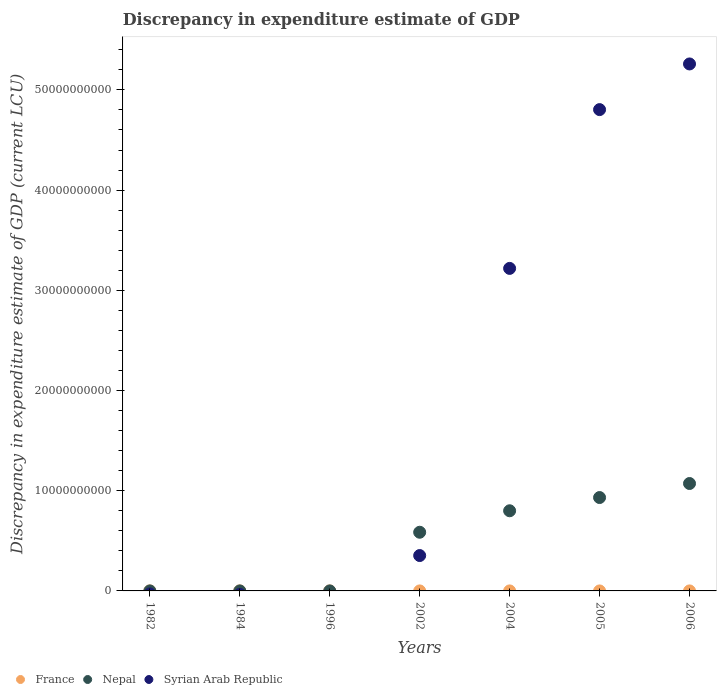What is the discrepancy in expenditure estimate of GDP in Nepal in 1984?
Your response must be concise. 9.9e-5. Across all years, what is the maximum discrepancy in expenditure estimate of GDP in Syrian Arab Republic?
Keep it short and to the point. 5.26e+1. What is the total discrepancy in expenditure estimate of GDP in Nepal in the graph?
Provide a succinct answer. 3.39e+1. What is the difference between the discrepancy in expenditure estimate of GDP in Syrian Arab Republic in 2004 and that in 2005?
Give a very brief answer. -1.58e+1. What is the average discrepancy in expenditure estimate of GDP in Nepal per year?
Provide a succinct answer. 4.84e+09. In the year 2002, what is the difference between the discrepancy in expenditure estimate of GDP in Nepal and discrepancy in expenditure estimate of GDP in Syrian Arab Republic?
Provide a short and direct response. 2.33e+09. Is the difference between the discrepancy in expenditure estimate of GDP in Nepal in 2004 and 2005 greater than the difference between the discrepancy in expenditure estimate of GDP in Syrian Arab Republic in 2004 and 2005?
Keep it short and to the point. Yes. What is the difference between the highest and the second highest discrepancy in expenditure estimate of GDP in France?
Your answer should be compact. 0. What is the difference between the highest and the lowest discrepancy in expenditure estimate of GDP in Nepal?
Ensure brevity in your answer.  1.07e+1. In how many years, is the discrepancy in expenditure estimate of GDP in Syrian Arab Republic greater than the average discrepancy in expenditure estimate of GDP in Syrian Arab Republic taken over all years?
Give a very brief answer. 3. Is the sum of the discrepancy in expenditure estimate of GDP in Syrian Arab Republic in 2002 and 2004 greater than the maximum discrepancy in expenditure estimate of GDP in Nepal across all years?
Make the answer very short. Yes. Is it the case that in every year, the sum of the discrepancy in expenditure estimate of GDP in Syrian Arab Republic and discrepancy in expenditure estimate of GDP in France  is greater than the discrepancy in expenditure estimate of GDP in Nepal?
Provide a succinct answer. No. Is the discrepancy in expenditure estimate of GDP in Syrian Arab Republic strictly greater than the discrepancy in expenditure estimate of GDP in France over the years?
Give a very brief answer. No. Is the discrepancy in expenditure estimate of GDP in Nepal strictly less than the discrepancy in expenditure estimate of GDP in France over the years?
Offer a terse response. No. How many dotlines are there?
Provide a short and direct response. 3. How many years are there in the graph?
Your response must be concise. 7. Are the values on the major ticks of Y-axis written in scientific E-notation?
Make the answer very short. No. Does the graph contain grids?
Your answer should be compact. No. How are the legend labels stacked?
Your response must be concise. Horizontal. What is the title of the graph?
Offer a very short reply. Discrepancy in expenditure estimate of GDP. Does "Azerbaijan" appear as one of the legend labels in the graph?
Keep it short and to the point. No. What is the label or title of the Y-axis?
Provide a short and direct response. Discrepancy in expenditure estimate of GDP (current LCU). What is the Discrepancy in expenditure estimate of GDP (current LCU) of France in 1982?
Give a very brief answer. 1.00e+06. What is the Discrepancy in expenditure estimate of GDP (current LCU) of Syrian Arab Republic in 1982?
Provide a succinct answer. 0. What is the Discrepancy in expenditure estimate of GDP (current LCU) of Nepal in 1984?
Keep it short and to the point. 9.9e-5. What is the Discrepancy in expenditure estimate of GDP (current LCU) in Syrian Arab Republic in 1984?
Provide a succinct answer. 0. What is the Discrepancy in expenditure estimate of GDP (current LCU) in France in 1996?
Make the answer very short. 0. What is the Discrepancy in expenditure estimate of GDP (current LCU) in France in 2002?
Your answer should be very brief. 1.00e+06. What is the Discrepancy in expenditure estimate of GDP (current LCU) of Nepal in 2002?
Give a very brief answer. 5.86e+09. What is the Discrepancy in expenditure estimate of GDP (current LCU) of Syrian Arab Republic in 2002?
Keep it short and to the point. 3.53e+09. What is the Discrepancy in expenditure estimate of GDP (current LCU) in France in 2004?
Provide a short and direct response. 1.00e+06. What is the Discrepancy in expenditure estimate of GDP (current LCU) of Nepal in 2004?
Your response must be concise. 8.00e+09. What is the Discrepancy in expenditure estimate of GDP (current LCU) of Syrian Arab Republic in 2004?
Your response must be concise. 3.22e+1. What is the Discrepancy in expenditure estimate of GDP (current LCU) of Nepal in 2005?
Your response must be concise. 9.32e+09. What is the Discrepancy in expenditure estimate of GDP (current LCU) of Syrian Arab Republic in 2005?
Offer a very short reply. 4.80e+1. What is the Discrepancy in expenditure estimate of GDP (current LCU) in Nepal in 2006?
Provide a short and direct response. 1.07e+1. What is the Discrepancy in expenditure estimate of GDP (current LCU) of Syrian Arab Republic in 2006?
Your response must be concise. 5.26e+1. Across all years, what is the maximum Discrepancy in expenditure estimate of GDP (current LCU) in France?
Your response must be concise. 1.00e+06. Across all years, what is the maximum Discrepancy in expenditure estimate of GDP (current LCU) in Nepal?
Your response must be concise. 1.07e+1. Across all years, what is the maximum Discrepancy in expenditure estimate of GDP (current LCU) in Syrian Arab Republic?
Give a very brief answer. 5.26e+1. Across all years, what is the minimum Discrepancy in expenditure estimate of GDP (current LCU) of France?
Offer a terse response. 0. What is the total Discrepancy in expenditure estimate of GDP (current LCU) of France in the graph?
Your answer should be compact. 5.00e+06. What is the total Discrepancy in expenditure estimate of GDP (current LCU) of Nepal in the graph?
Provide a short and direct response. 3.39e+1. What is the total Discrepancy in expenditure estimate of GDP (current LCU) in Syrian Arab Republic in the graph?
Your answer should be compact. 1.36e+11. What is the difference between the Discrepancy in expenditure estimate of GDP (current LCU) in France in 1982 and that in 1984?
Your answer should be compact. 0. What is the difference between the Discrepancy in expenditure estimate of GDP (current LCU) in France in 1982 and that in 2006?
Ensure brevity in your answer.  0. What is the difference between the Discrepancy in expenditure estimate of GDP (current LCU) of Nepal in 1984 and that in 2002?
Keep it short and to the point. -5.85e+09. What is the difference between the Discrepancy in expenditure estimate of GDP (current LCU) of France in 1984 and that in 2004?
Keep it short and to the point. 0. What is the difference between the Discrepancy in expenditure estimate of GDP (current LCU) of Nepal in 1984 and that in 2004?
Give a very brief answer. -8.00e+09. What is the difference between the Discrepancy in expenditure estimate of GDP (current LCU) in Nepal in 1984 and that in 2005?
Your answer should be very brief. -9.32e+09. What is the difference between the Discrepancy in expenditure estimate of GDP (current LCU) in Nepal in 1984 and that in 2006?
Your response must be concise. -1.07e+1. What is the difference between the Discrepancy in expenditure estimate of GDP (current LCU) of France in 2002 and that in 2004?
Your answer should be compact. 0. What is the difference between the Discrepancy in expenditure estimate of GDP (current LCU) in Nepal in 2002 and that in 2004?
Give a very brief answer. -2.14e+09. What is the difference between the Discrepancy in expenditure estimate of GDP (current LCU) in Syrian Arab Republic in 2002 and that in 2004?
Provide a succinct answer. -2.87e+1. What is the difference between the Discrepancy in expenditure estimate of GDP (current LCU) of Nepal in 2002 and that in 2005?
Your answer should be very brief. -3.46e+09. What is the difference between the Discrepancy in expenditure estimate of GDP (current LCU) of Syrian Arab Republic in 2002 and that in 2005?
Offer a terse response. -4.45e+1. What is the difference between the Discrepancy in expenditure estimate of GDP (current LCU) in Nepal in 2002 and that in 2006?
Your answer should be compact. -4.86e+09. What is the difference between the Discrepancy in expenditure estimate of GDP (current LCU) of Syrian Arab Republic in 2002 and that in 2006?
Keep it short and to the point. -4.91e+1. What is the difference between the Discrepancy in expenditure estimate of GDP (current LCU) of Nepal in 2004 and that in 2005?
Give a very brief answer. -1.32e+09. What is the difference between the Discrepancy in expenditure estimate of GDP (current LCU) in Syrian Arab Republic in 2004 and that in 2005?
Your answer should be compact. -1.58e+1. What is the difference between the Discrepancy in expenditure estimate of GDP (current LCU) of France in 2004 and that in 2006?
Offer a very short reply. 0. What is the difference between the Discrepancy in expenditure estimate of GDP (current LCU) of Nepal in 2004 and that in 2006?
Make the answer very short. -2.72e+09. What is the difference between the Discrepancy in expenditure estimate of GDP (current LCU) in Syrian Arab Republic in 2004 and that in 2006?
Give a very brief answer. -2.04e+1. What is the difference between the Discrepancy in expenditure estimate of GDP (current LCU) of Nepal in 2005 and that in 2006?
Give a very brief answer. -1.40e+09. What is the difference between the Discrepancy in expenditure estimate of GDP (current LCU) of Syrian Arab Republic in 2005 and that in 2006?
Your response must be concise. -4.56e+09. What is the difference between the Discrepancy in expenditure estimate of GDP (current LCU) of France in 1982 and the Discrepancy in expenditure estimate of GDP (current LCU) of Nepal in 1984?
Ensure brevity in your answer.  1.00e+06. What is the difference between the Discrepancy in expenditure estimate of GDP (current LCU) of France in 1982 and the Discrepancy in expenditure estimate of GDP (current LCU) of Nepal in 2002?
Your answer should be compact. -5.85e+09. What is the difference between the Discrepancy in expenditure estimate of GDP (current LCU) of France in 1982 and the Discrepancy in expenditure estimate of GDP (current LCU) of Syrian Arab Republic in 2002?
Keep it short and to the point. -3.53e+09. What is the difference between the Discrepancy in expenditure estimate of GDP (current LCU) of France in 1982 and the Discrepancy in expenditure estimate of GDP (current LCU) of Nepal in 2004?
Offer a very short reply. -8.00e+09. What is the difference between the Discrepancy in expenditure estimate of GDP (current LCU) in France in 1982 and the Discrepancy in expenditure estimate of GDP (current LCU) in Syrian Arab Republic in 2004?
Your answer should be compact. -3.22e+1. What is the difference between the Discrepancy in expenditure estimate of GDP (current LCU) in France in 1982 and the Discrepancy in expenditure estimate of GDP (current LCU) in Nepal in 2005?
Offer a terse response. -9.32e+09. What is the difference between the Discrepancy in expenditure estimate of GDP (current LCU) in France in 1982 and the Discrepancy in expenditure estimate of GDP (current LCU) in Syrian Arab Republic in 2005?
Your response must be concise. -4.80e+1. What is the difference between the Discrepancy in expenditure estimate of GDP (current LCU) of France in 1982 and the Discrepancy in expenditure estimate of GDP (current LCU) of Nepal in 2006?
Your answer should be compact. -1.07e+1. What is the difference between the Discrepancy in expenditure estimate of GDP (current LCU) in France in 1982 and the Discrepancy in expenditure estimate of GDP (current LCU) in Syrian Arab Republic in 2006?
Your answer should be compact. -5.26e+1. What is the difference between the Discrepancy in expenditure estimate of GDP (current LCU) of France in 1984 and the Discrepancy in expenditure estimate of GDP (current LCU) of Nepal in 2002?
Your answer should be very brief. -5.85e+09. What is the difference between the Discrepancy in expenditure estimate of GDP (current LCU) of France in 1984 and the Discrepancy in expenditure estimate of GDP (current LCU) of Syrian Arab Republic in 2002?
Keep it short and to the point. -3.53e+09. What is the difference between the Discrepancy in expenditure estimate of GDP (current LCU) of Nepal in 1984 and the Discrepancy in expenditure estimate of GDP (current LCU) of Syrian Arab Republic in 2002?
Offer a terse response. -3.53e+09. What is the difference between the Discrepancy in expenditure estimate of GDP (current LCU) in France in 1984 and the Discrepancy in expenditure estimate of GDP (current LCU) in Nepal in 2004?
Keep it short and to the point. -8.00e+09. What is the difference between the Discrepancy in expenditure estimate of GDP (current LCU) of France in 1984 and the Discrepancy in expenditure estimate of GDP (current LCU) of Syrian Arab Republic in 2004?
Provide a short and direct response. -3.22e+1. What is the difference between the Discrepancy in expenditure estimate of GDP (current LCU) in Nepal in 1984 and the Discrepancy in expenditure estimate of GDP (current LCU) in Syrian Arab Republic in 2004?
Give a very brief answer. -3.22e+1. What is the difference between the Discrepancy in expenditure estimate of GDP (current LCU) in France in 1984 and the Discrepancy in expenditure estimate of GDP (current LCU) in Nepal in 2005?
Make the answer very short. -9.32e+09. What is the difference between the Discrepancy in expenditure estimate of GDP (current LCU) of France in 1984 and the Discrepancy in expenditure estimate of GDP (current LCU) of Syrian Arab Republic in 2005?
Keep it short and to the point. -4.80e+1. What is the difference between the Discrepancy in expenditure estimate of GDP (current LCU) in Nepal in 1984 and the Discrepancy in expenditure estimate of GDP (current LCU) in Syrian Arab Republic in 2005?
Your response must be concise. -4.80e+1. What is the difference between the Discrepancy in expenditure estimate of GDP (current LCU) of France in 1984 and the Discrepancy in expenditure estimate of GDP (current LCU) of Nepal in 2006?
Your answer should be compact. -1.07e+1. What is the difference between the Discrepancy in expenditure estimate of GDP (current LCU) in France in 1984 and the Discrepancy in expenditure estimate of GDP (current LCU) in Syrian Arab Republic in 2006?
Keep it short and to the point. -5.26e+1. What is the difference between the Discrepancy in expenditure estimate of GDP (current LCU) of Nepal in 1984 and the Discrepancy in expenditure estimate of GDP (current LCU) of Syrian Arab Republic in 2006?
Make the answer very short. -5.26e+1. What is the difference between the Discrepancy in expenditure estimate of GDP (current LCU) in France in 2002 and the Discrepancy in expenditure estimate of GDP (current LCU) in Nepal in 2004?
Ensure brevity in your answer.  -8.00e+09. What is the difference between the Discrepancy in expenditure estimate of GDP (current LCU) of France in 2002 and the Discrepancy in expenditure estimate of GDP (current LCU) of Syrian Arab Republic in 2004?
Your answer should be compact. -3.22e+1. What is the difference between the Discrepancy in expenditure estimate of GDP (current LCU) in Nepal in 2002 and the Discrepancy in expenditure estimate of GDP (current LCU) in Syrian Arab Republic in 2004?
Give a very brief answer. -2.63e+1. What is the difference between the Discrepancy in expenditure estimate of GDP (current LCU) in France in 2002 and the Discrepancy in expenditure estimate of GDP (current LCU) in Nepal in 2005?
Give a very brief answer. -9.32e+09. What is the difference between the Discrepancy in expenditure estimate of GDP (current LCU) in France in 2002 and the Discrepancy in expenditure estimate of GDP (current LCU) in Syrian Arab Republic in 2005?
Give a very brief answer. -4.80e+1. What is the difference between the Discrepancy in expenditure estimate of GDP (current LCU) of Nepal in 2002 and the Discrepancy in expenditure estimate of GDP (current LCU) of Syrian Arab Republic in 2005?
Your response must be concise. -4.22e+1. What is the difference between the Discrepancy in expenditure estimate of GDP (current LCU) of France in 2002 and the Discrepancy in expenditure estimate of GDP (current LCU) of Nepal in 2006?
Your answer should be very brief. -1.07e+1. What is the difference between the Discrepancy in expenditure estimate of GDP (current LCU) in France in 2002 and the Discrepancy in expenditure estimate of GDP (current LCU) in Syrian Arab Republic in 2006?
Your response must be concise. -5.26e+1. What is the difference between the Discrepancy in expenditure estimate of GDP (current LCU) of Nepal in 2002 and the Discrepancy in expenditure estimate of GDP (current LCU) of Syrian Arab Republic in 2006?
Make the answer very short. -4.67e+1. What is the difference between the Discrepancy in expenditure estimate of GDP (current LCU) of France in 2004 and the Discrepancy in expenditure estimate of GDP (current LCU) of Nepal in 2005?
Offer a very short reply. -9.32e+09. What is the difference between the Discrepancy in expenditure estimate of GDP (current LCU) in France in 2004 and the Discrepancy in expenditure estimate of GDP (current LCU) in Syrian Arab Republic in 2005?
Make the answer very short. -4.80e+1. What is the difference between the Discrepancy in expenditure estimate of GDP (current LCU) of Nepal in 2004 and the Discrepancy in expenditure estimate of GDP (current LCU) of Syrian Arab Republic in 2005?
Your answer should be very brief. -4.00e+1. What is the difference between the Discrepancy in expenditure estimate of GDP (current LCU) in France in 2004 and the Discrepancy in expenditure estimate of GDP (current LCU) in Nepal in 2006?
Make the answer very short. -1.07e+1. What is the difference between the Discrepancy in expenditure estimate of GDP (current LCU) of France in 2004 and the Discrepancy in expenditure estimate of GDP (current LCU) of Syrian Arab Republic in 2006?
Make the answer very short. -5.26e+1. What is the difference between the Discrepancy in expenditure estimate of GDP (current LCU) in Nepal in 2004 and the Discrepancy in expenditure estimate of GDP (current LCU) in Syrian Arab Republic in 2006?
Make the answer very short. -4.46e+1. What is the difference between the Discrepancy in expenditure estimate of GDP (current LCU) in Nepal in 2005 and the Discrepancy in expenditure estimate of GDP (current LCU) in Syrian Arab Republic in 2006?
Your answer should be very brief. -4.33e+1. What is the average Discrepancy in expenditure estimate of GDP (current LCU) in France per year?
Make the answer very short. 7.14e+05. What is the average Discrepancy in expenditure estimate of GDP (current LCU) in Nepal per year?
Provide a succinct answer. 4.84e+09. What is the average Discrepancy in expenditure estimate of GDP (current LCU) of Syrian Arab Republic per year?
Offer a terse response. 1.95e+1. In the year 1984, what is the difference between the Discrepancy in expenditure estimate of GDP (current LCU) of France and Discrepancy in expenditure estimate of GDP (current LCU) of Nepal?
Your response must be concise. 1.00e+06. In the year 2002, what is the difference between the Discrepancy in expenditure estimate of GDP (current LCU) in France and Discrepancy in expenditure estimate of GDP (current LCU) in Nepal?
Provide a short and direct response. -5.85e+09. In the year 2002, what is the difference between the Discrepancy in expenditure estimate of GDP (current LCU) in France and Discrepancy in expenditure estimate of GDP (current LCU) in Syrian Arab Republic?
Keep it short and to the point. -3.53e+09. In the year 2002, what is the difference between the Discrepancy in expenditure estimate of GDP (current LCU) of Nepal and Discrepancy in expenditure estimate of GDP (current LCU) of Syrian Arab Republic?
Your answer should be very brief. 2.33e+09. In the year 2004, what is the difference between the Discrepancy in expenditure estimate of GDP (current LCU) in France and Discrepancy in expenditure estimate of GDP (current LCU) in Nepal?
Ensure brevity in your answer.  -8.00e+09. In the year 2004, what is the difference between the Discrepancy in expenditure estimate of GDP (current LCU) of France and Discrepancy in expenditure estimate of GDP (current LCU) of Syrian Arab Republic?
Make the answer very short. -3.22e+1. In the year 2004, what is the difference between the Discrepancy in expenditure estimate of GDP (current LCU) in Nepal and Discrepancy in expenditure estimate of GDP (current LCU) in Syrian Arab Republic?
Provide a succinct answer. -2.42e+1. In the year 2005, what is the difference between the Discrepancy in expenditure estimate of GDP (current LCU) of Nepal and Discrepancy in expenditure estimate of GDP (current LCU) of Syrian Arab Republic?
Your answer should be very brief. -3.87e+1. In the year 2006, what is the difference between the Discrepancy in expenditure estimate of GDP (current LCU) of France and Discrepancy in expenditure estimate of GDP (current LCU) of Nepal?
Make the answer very short. -1.07e+1. In the year 2006, what is the difference between the Discrepancy in expenditure estimate of GDP (current LCU) of France and Discrepancy in expenditure estimate of GDP (current LCU) of Syrian Arab Republic?
Make the answer very short. -5.26e+1. In the year 2006, what is the difference between the Discrepancy in expenditure estimate of GDP (current LCU) of Nepal and Discrepancy in expenditure estimate of GDP (current LCU) of Syrian Arab Republic?
Give a very brief answer. -4.19e+1. What is the ratio of the Discrepancy in expenditure estimate of GDP (current LCU) in France in 1982 to that in 1984?
Offer a very short reply. 1. What is the ratio of the Discrepancy in expenditure estimate of GDP (current LCU) of France in 1982 to that in 2002?
Offer a very short reply. 1. What is the ratio of the Discrepancy in expenditure estimate of GDP (current LCU) in France in 1982 to that in 2004?
Provide a short and direct response. 1. What is the ratio of the Discrepancy in expenditure estimate of GDP (current LCU) of France in 1984 to that in 2002?
Keep it short and to the point. 1. What is the ratio of the Discrepancy in expenditure estimate of GDP (current LCU) of France in 1984 to that in 2004?
Make the answer very short. 1. What is the ratio of the Discrepancy in expenditure estimate of GDP (current LCU) of Nepal in 1984 to that in 2005?
Provide a succinct answer. 0. What is the ratio of the Discrepancy in expenditure estimate of GDP (current LCU) of France in 2002 to that in 2004?
Your answer should be compact. 1. What is the ratio of the Discrepancy in expenditure estimate of GDP (current LCU) in Nepal in 2002 to that in 2004?
Give a very brief answer. 0.73. What is the ratio of the Discrepancy in expenditure estimate of GDP (current LCU) of Syrian Arab Republic in 2002 to that in 2004?
Your answer should be very brief. 0.11. What is the ratio of the Discrepancy in expenditure estimate of GDP (current LCU) of Nepal in 2002 to that in 2005?
Your answer should be compact. 0.63. What is the ratio of the Discrepancy in expenditure estimate of GDP (current LCU) in Syrian Arab Republic in 2002 to that in 2005?
Your answer should be compact. 0.07. What is the ratio of the Discrepancy in expenditure estimate of GDP (current LCU) of France in 2002 to that in 2006?
Make the answer very short. 1. What is the ratio of the Discrepancy in expenditure estimate of GDP (current LCU) of Nepal in 2002 to that in 2006?
Ensure brevity in your answer.  0.55. What is the ratio of the Discrepancy in expenditure estimate of GDP (current LCU) in Syrian Arab Republic in 2002 to that in 2006?
Provide a succinct answer. 0.07. What is the ratio of the Discrepancy in expenditure estimate of GDP (current LCU) of Nepal in 2004 to that in 2005?
Provide a short and direct response. 0.86. What is the ratio of the Discrepancy in expenditure estimate of GDP (current LCU) of Syrian Arab Republic in 2004 to that in 2005?
Provide a short and direct response. 0.67. What is the ratio of the Discrepancy in expenditure estimate of GDP (current LCU) in Nepal in 2004 to that in 2006?
Ensure brevity in your answer.  0.75. What is the ratio of the Discrepancy in expenditure estimate of GDP (current LCU) in Syrian Arab Republic in 2004 to that in 2006?
Make the answer very short. 0.61. What is the ratio of the Discrepancy in expenditure estimate of GDP (current LCU) in Nepal in 2005 to that in 2006?
Provide a succinct answer. 0.87. What is the ratio of the Discrepancy in expenditure estimate of GDP (current LCU) in Syrian Arab Republic in 2005 to that in 2006?
Make the answer very short. 0.91. What is the difference between the highest and the second highest Discrepancy in expenditure estimate of GDP (current LCU) in Nepal?
Your answer should be compact. 1.40e+09. What is the difference between the highest and the second highest Discrepancy in expenditure estimate of GDP (current LCU) of Syrian Arab Republic?
Your answer should be compact. 4.56e+09. What is the difference between the highest and the lowest Discrepancy in expenditure estimate of GDP (current LCU) in France?
Provide a succinct answer. 1.00e+06. What is the difference between the highest and the lowest Discrepancy in expenditure estimate of GDP (current LCU) in Nepal?
Ensure brevity in your answer.  1.07e+1. What is the difference between the highest and the lowest Discrepancy in expenditure estimate of GDP (current LCU) of Syrian Arab Republic?
Your answer should be very brief. 5.26e+1. 